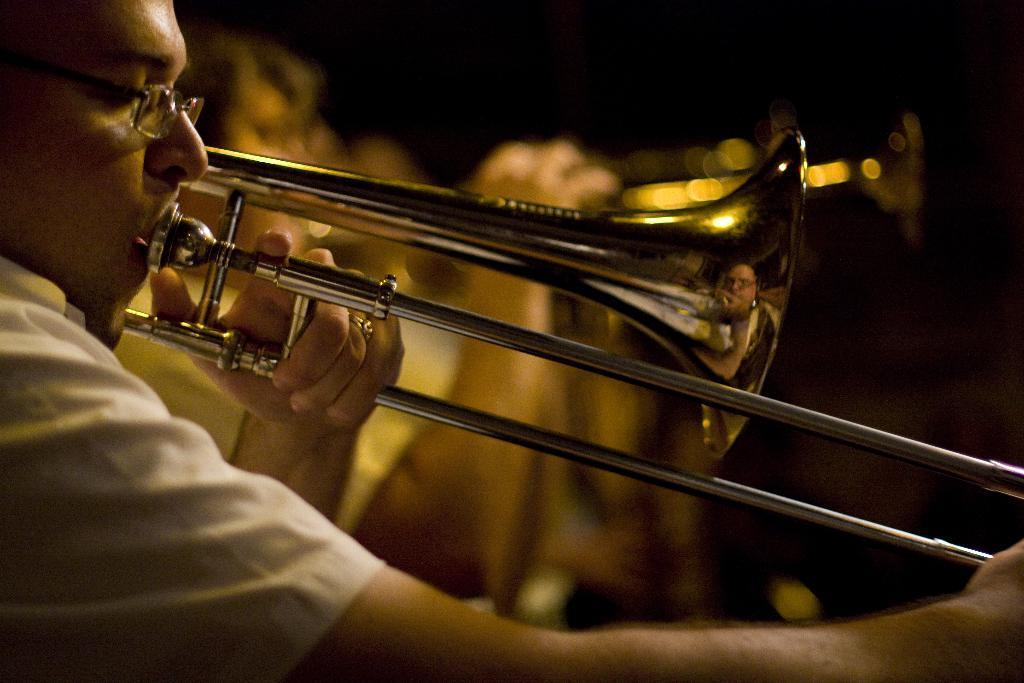Could you give a brief overview of what you see in this image? In this image there are people playing musical instruments. 